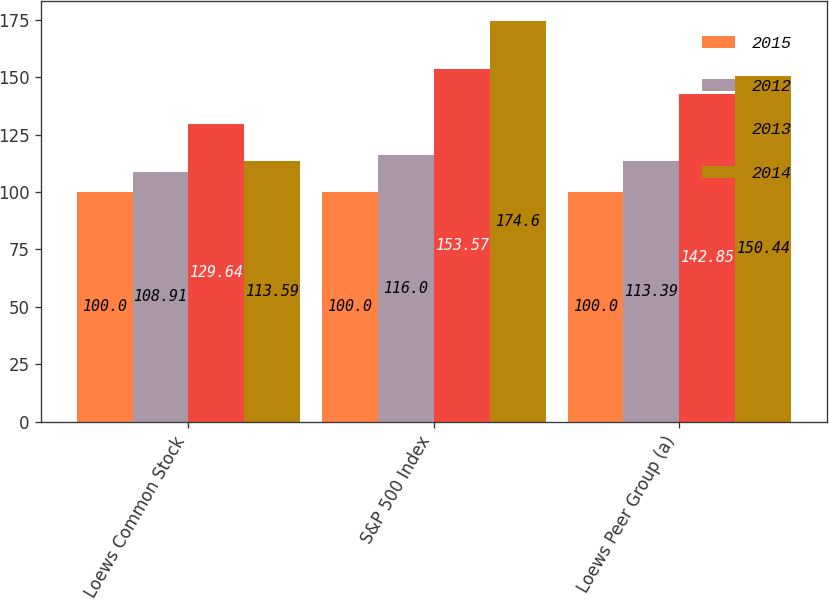Convert chart. <chart><loc_0><loc_0><loc_500><loc_500><stacked_bar_chart><ecel><fcel>Loews Common Stock<fcel>S&P 500 Index<fcel>Loews Peer Group (a)<nl><fcel>2015<fcel>100<fcel>100<fcel>100<nl><fcel>2012<fcel>108.91<fcel>116<fcel>113.39<nl><fcel>2013<fcel>129.64<fcel>153.57<fcel>142.85<nl><fcel>2014<fcel>113.59<fcel>174.6<fcel>150.44<nl></chart> 